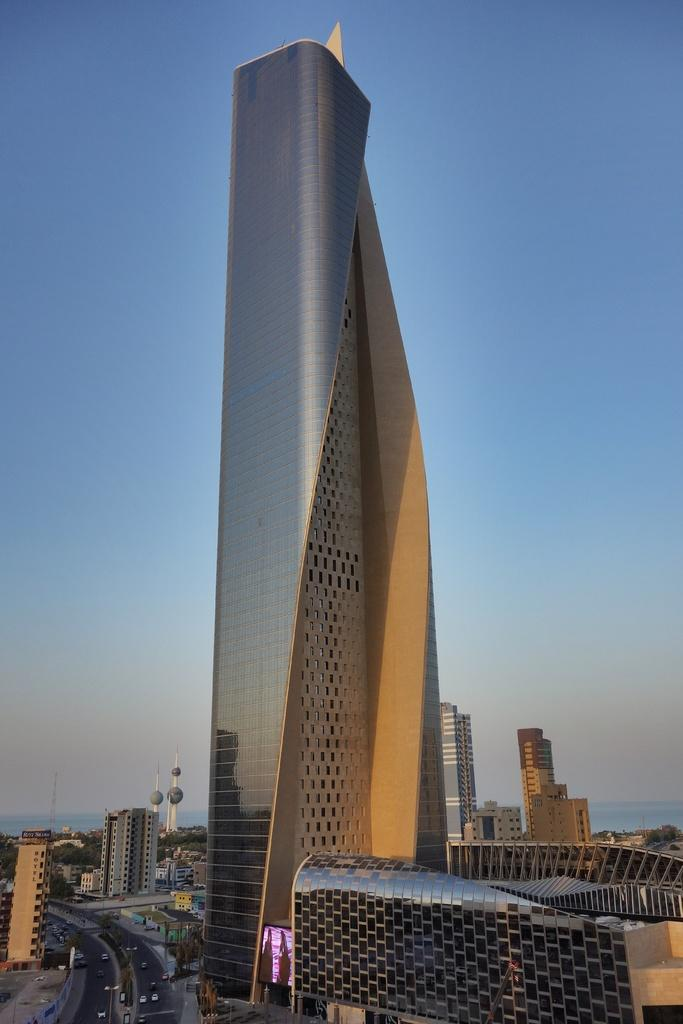What type of structures can be seen in the image? There are buildings in the image. What feature do the buildings have? The buildings have windows. What else can be seen on the ground in the image? There are vehicles on the road. What is the tallest structure in the image? There is a tower in the image. What natural element is visible in the image? Water is visible in the image. What is the color of the sky in the image? The sky is pale blue in color. What type of curtain can be seen hanging from the tower in the image? There is no curtain hanging from the tower in the image; it is a tall structure without any visible curtains. Can you tell me how many cups are on the table in the image? There is no table or cups present in the image. 